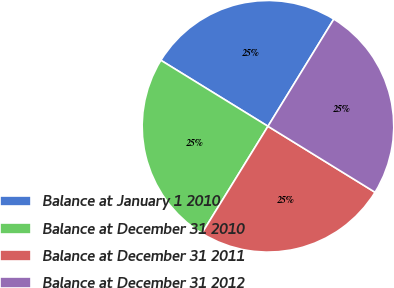<chart> <loc_0><loc_0><loc_500><loc_500><pie_chart><fcel>Balance at January 1 2010<fcel>Balance at December 31 2010<fcel>Balance at December 31 2011<fcel>Balance at December 31 2012<nl><fcel>24.98%<fcel>24.99%<fcel>25.01%<fcel>25.02%<nl></chart> 